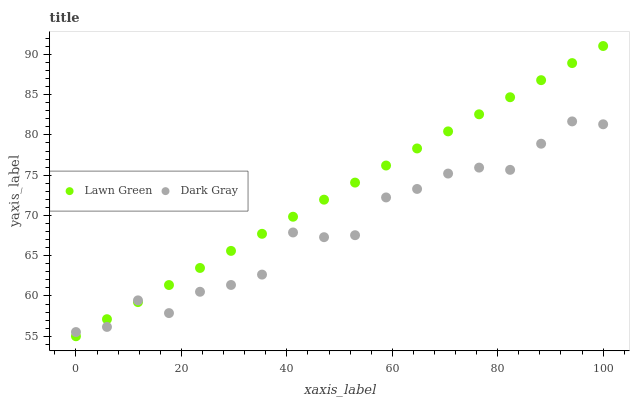Does Dark Gray have the minimum area under the curve?
Answer yes or no. Yes. Does Lawn Green have the maximum area under the curve?
Answer yes or no. Yes. Does Lawn Green have the minimum area under the curve?
Answer yes or no. No. Is Lawn Green the smoothest?
Answer yes or no. Yes. Is Dark Gray the roughest?
Answer yes or no. Yes. Is Lawn Green the roughest?
Answer yes or no. No. Does Lawn Green have the lowest value?
Answer yes or no. Yes. Does Lawn Green have the highest value?
Answer yes or no. Yes. Does Lawn Green intersect Dark Gray?
Answer yes or no. Yes. Is Lawn Green less than Dark Gray?
Answer yes or no. No. Is Lawn Green greater than Dark Gray?
Answer yes or no. No. 